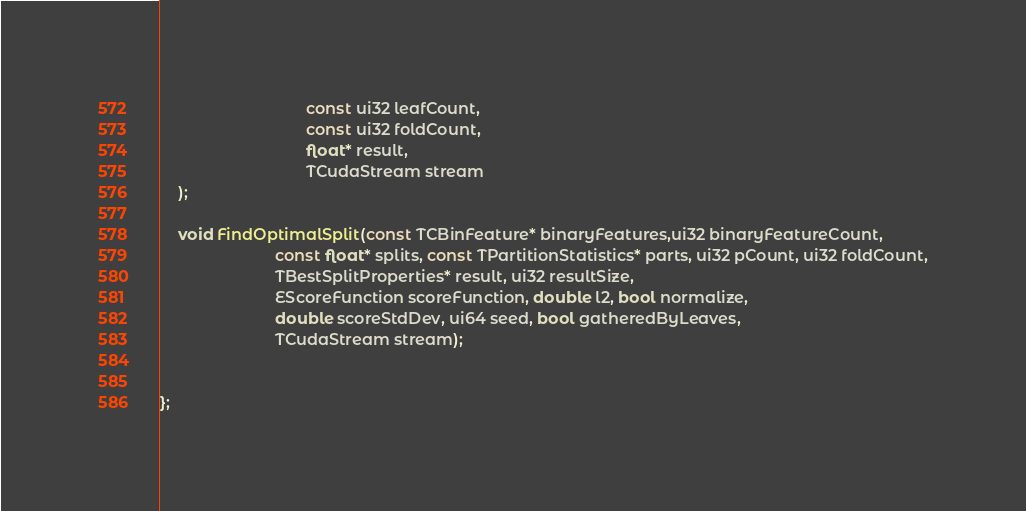<code> <loc_0><loc_0><loc_500><loc_500><_Cuda_>                                 const ui32 leafCount,
                                 const ui32 foldCount,
                                 float* result,
                                 TCudaStream stream
    );

    void FindOptimalSplit(const TCBinFeature* binaryFeatures,ui32 binaryFeatureCount,
                          const float* splits, const TPartitionStatistics* parts, ui32 pCount, ui32 foldCount,
                          TBestSplitProperties* result, ui32 resultSize,
                          EScoreFunction scoreFunction, double l2, bool normalize,
                          double scoreStdDev, ui64 seed, bool gatheredByLeaves,
                          TCudaStream stream);


};
</code> 